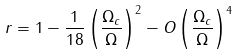Convert formula to latex. <formula><loc_0><loc_0><loc_500><loc_500>r = 1 - \frac { 1 } { 1 8 } \left ( \frac { \Omega _ { c } } { \Omega } \right ) ^ { 2 } - O \left ( \frac { \Omega _ { c } } { \Omega } \right ) ^ { 4 }</formula> 